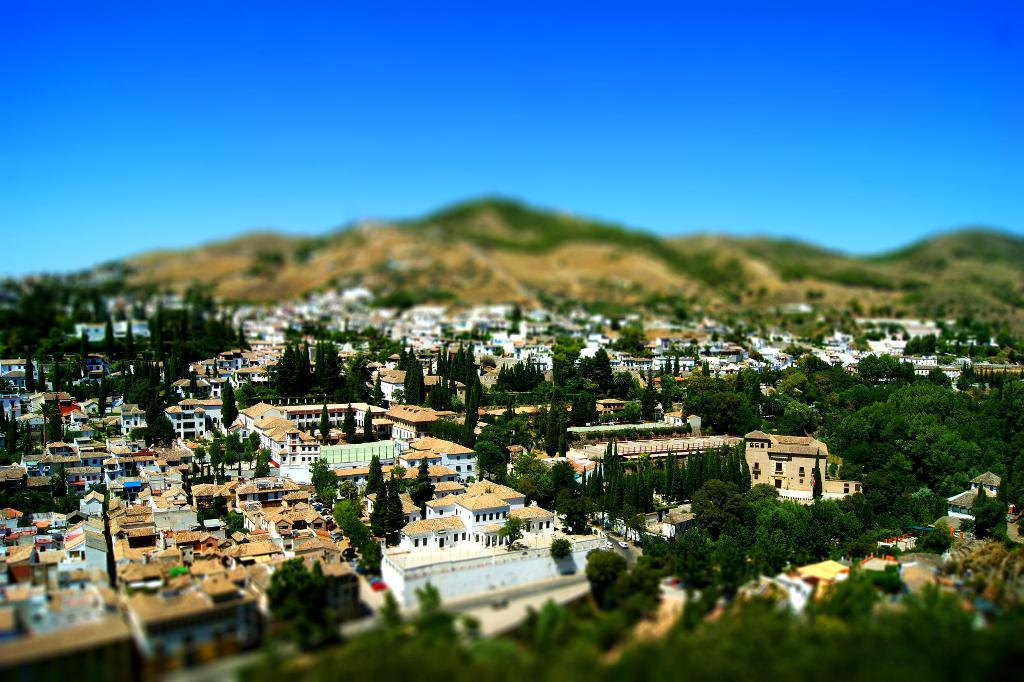What type of structures can be seen in the image? There are houses and buildings in the image. What other natural elements are present in the image? There are trees in the image. What can be seen in the distance in the image? There are hills visible in the background of the image. What is visible at the top of the image? The sky is visible at the top of the image. Can you see a family playing on the seashore in the image? There is no seashore or family playing in the image; it features houses, buildings, trees, hills, and the sky. 